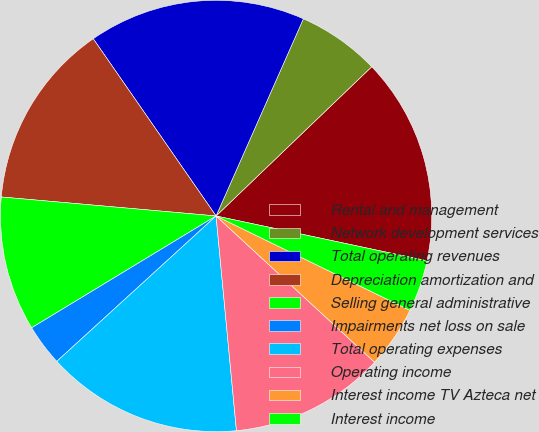Convert chart to OTSL. <chart><loc_0><loc_0><loc_500><loc_500><pie_chart><fcel>Rental and management<fcel>Network development services<fcel>Total operating revenues<fcel>Depreciation amortization and<fcel>Selling general administrative<fcel>Impairments net loss on sale<fcel>Total operating expenses<fcel>Operating income<fcel>Interest income TV Azteca net<fcel>Interest income<nl><fcel>15.5%<fcel>6.2%<fcel>16.28%<fcel>13.95%<fcel>10.08%<fcel>3.1%<fcel>14.73%<fcel>11.63%<fcel>4.65%<fcel>3.88%<nl></chart> 